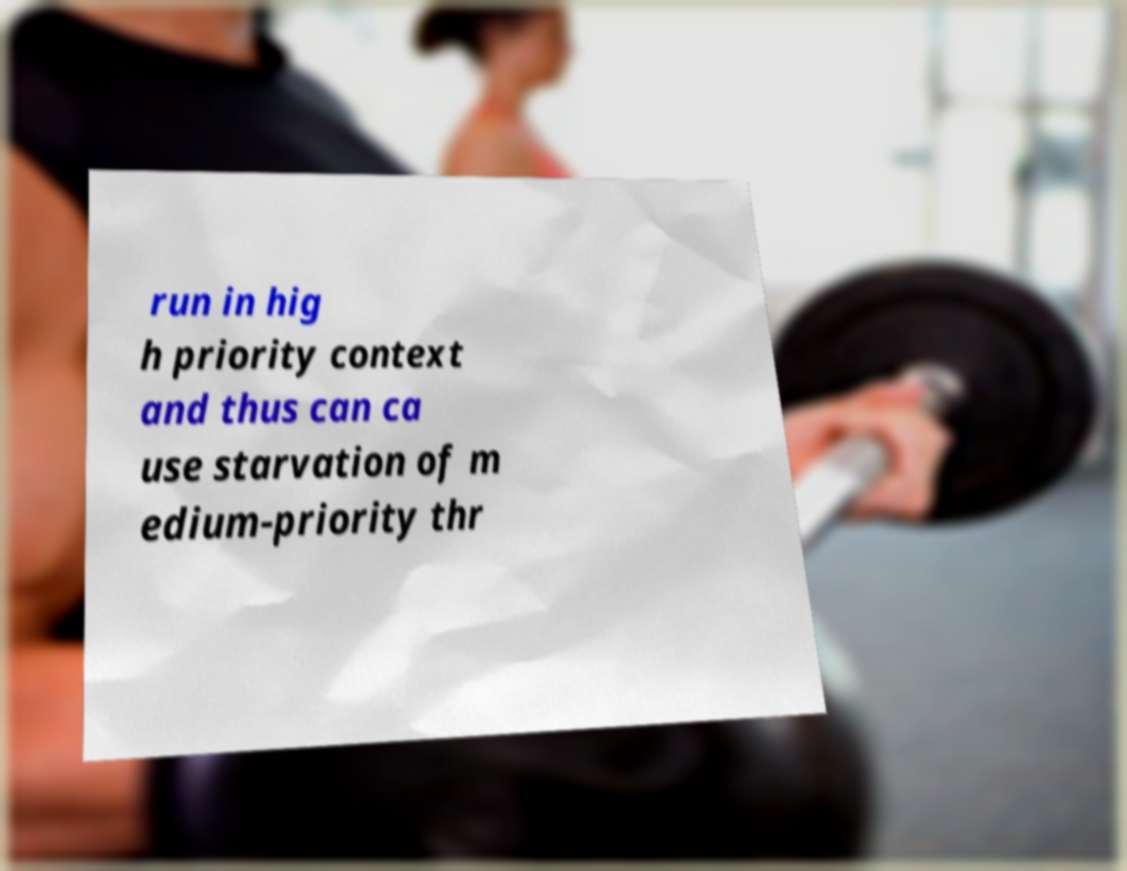What messages or text are displayed in this image? I need them in a readable, typed format. run in hig h priority context and thus can ca use starvation of m edium-priority thr 